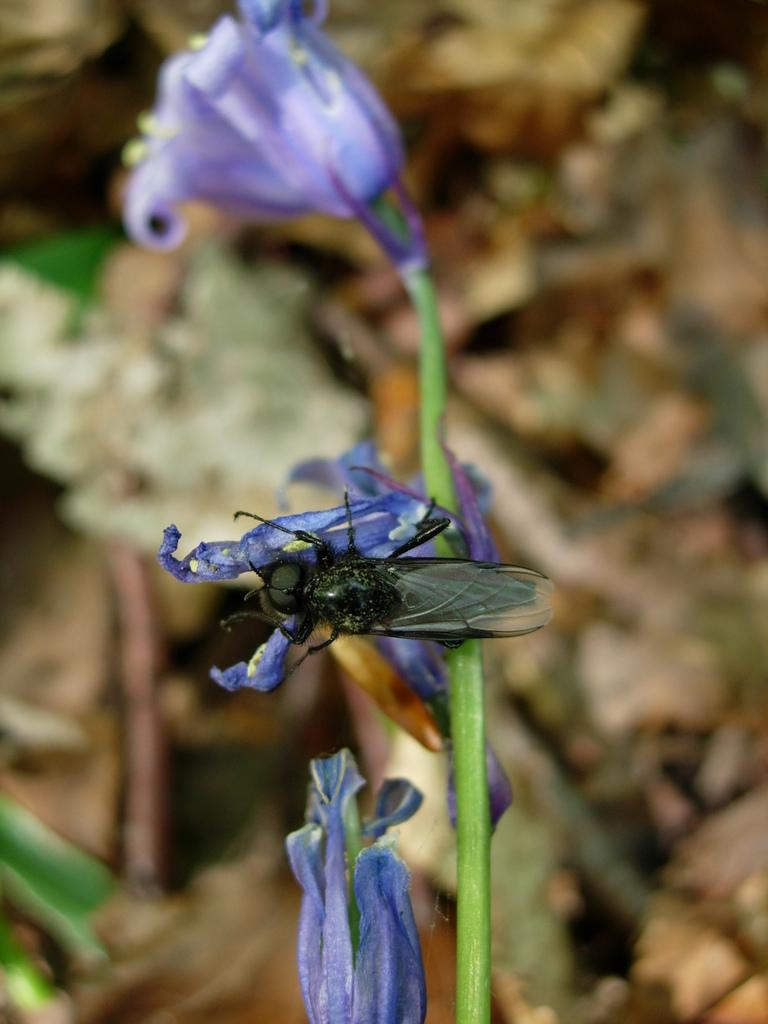What is the main subject of the image? The main subject of the image is a stem with flowers. Are there any additional elements present on the flowers? Yes, there is an insect on one of the flowers. How would you describe the background of the image? The background of the image is blurred. What type of ornament is hanging from the arch in the image? There is no ornament or arch present in the image; it features a stem with flowers and a blurred background. 